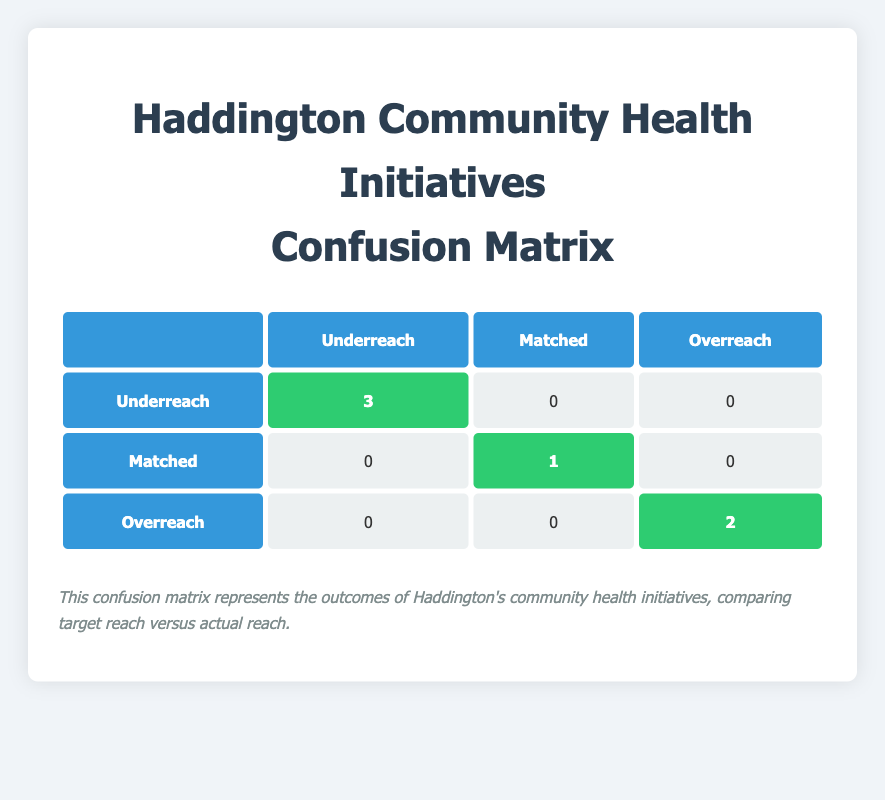What is the total number of initiatives that experienced underreach? The confusion matrix shows that there are three initiatives categorized under the "Underreach" outcome.
Answer: 3 What is the outcome of the Haddington Nutrition Workshop Series? The table indicates that the outcome for the Haddington Nutrition Workshop Series is "Matched," as its target reach and actual reach are both 80.
Answer: Matched Did the Haddington Diabetes Awareness Campaign overreach its target? According to the table, the actual reach of 220 exceeds the target reach of 200 for the Diabetes Awareness Campaign, confirming that it did overreach.
Answer: Yes How many initiatives matched their target reach? The table lists only one initiative, the Haddington Nutrition Workshop Series, that matched its target reach of 80.
Answer: 1 What is the difference between the target reach and actual reach for the Haddington Healthy Heart Program? The target reach for this initiative is 150 and the actual reach is 120, so the difference is 150 - 120 = 30.
Answer: 30 How many initiatives had an overreach outcome? From the confusion matrix, it can be seen that two initiatives are classified under the "Overreach" outcome.
Answer: 2 What is the percentage of initiatives that underreached their target based on the total initiatives? There are a total of 6 initiatives, and 3 underreached, resulting in a percentage of (3/6) * 100 = 50%.
Answer: 50% Which outcome is represented by the highlighted cell in the “Matched” row? The highlighted cell in the “Matched” row represents the outcome of 1 initiative that achieved its target, as shown by the highlighted number in the table.
Answer: 1 What would happen if one more initiative achieved its target reach in the Haddington community health initiatives? If one additional initiative achieves its target, the count of initiatives meeting their target would increase to 2, from the initial 1 reflected in the table.
Answer: 2 